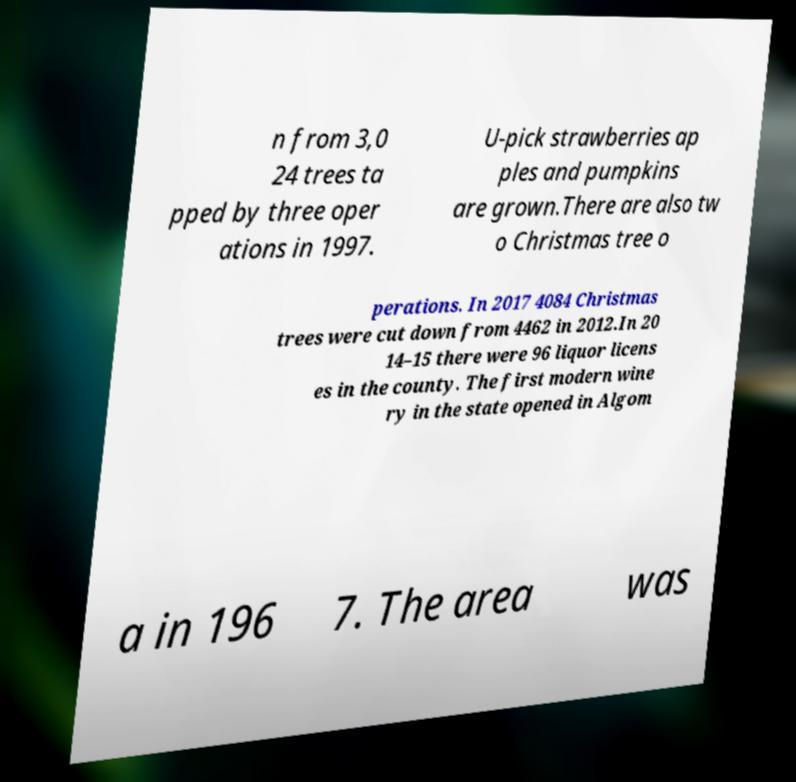There's text embedded in this image that I need extracted. Can you transcribe it verbatim? n from 3,0 24 trees ta pped by three oper ations in 1997. U-pick strawberries ap ples and pumpkins are grown.There are also tw o Christmas tree o perations. In 2017 4084 Christmas trees were cut down from 4462 in 2012.In 20 14–15 there were 96 liquor licens es in the county. The first modern wine ry in the state opened in Algom a in 196 7. The area was 